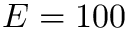<formula> <loc_0><loc_0><loc_500><loc_500>E = 1 0 0</formula> 